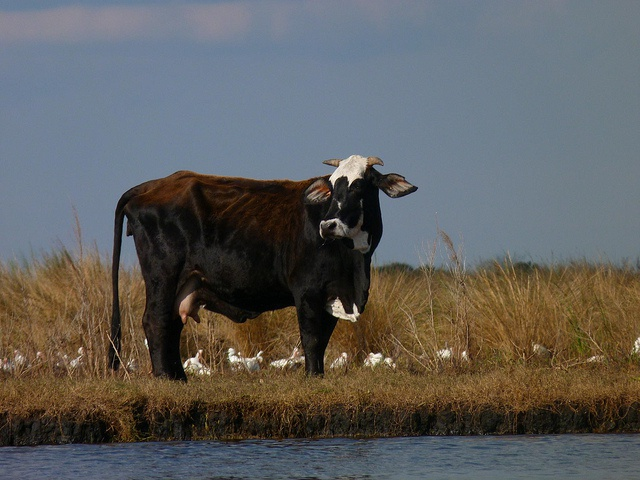Describe the objects in this image and their specific colors. I can see cow in gray, black, and maroon tones, bird in gray and maroon tones, bird in gray, maroon, and darkgray tones, bird in gray, lightgray, tan, and darkgray tones, and bird in gray and darkgray tones in this image. 